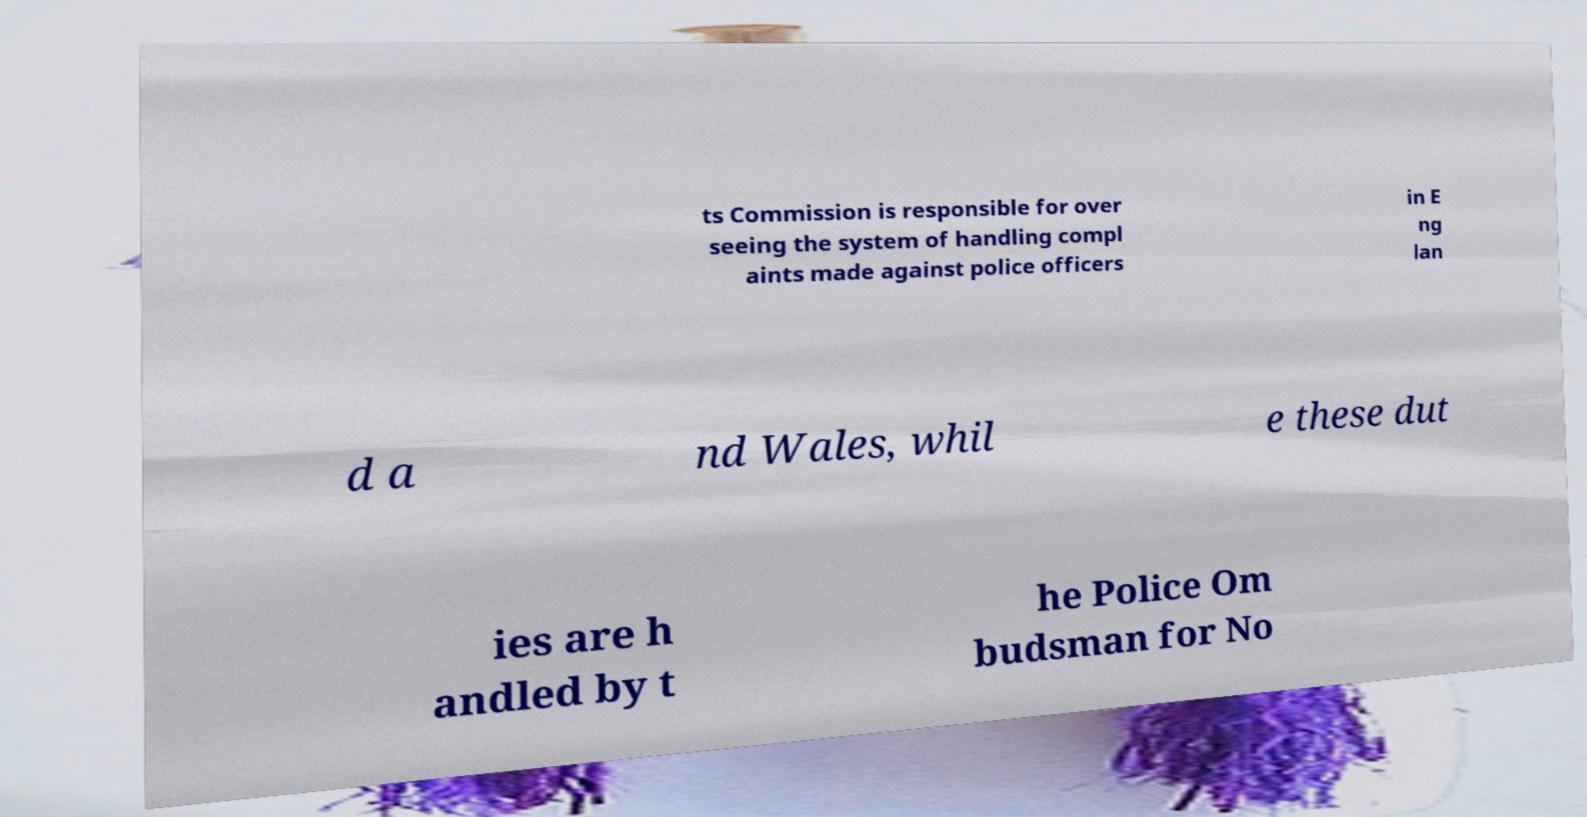Could you extract and type out the text from this image? ts Commission is responsible for over seeing the system of handling compl aints made against police officers in E ng lan d a nd Wales, whil e these dut ies are h andled by t he Police Om budsman for No 